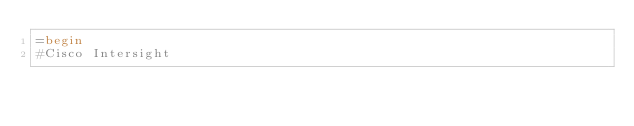<code> <loc_0><loc_0><loc_500><loc_500><_Ruby_>=begin
#Cisco Intersight
</code> 